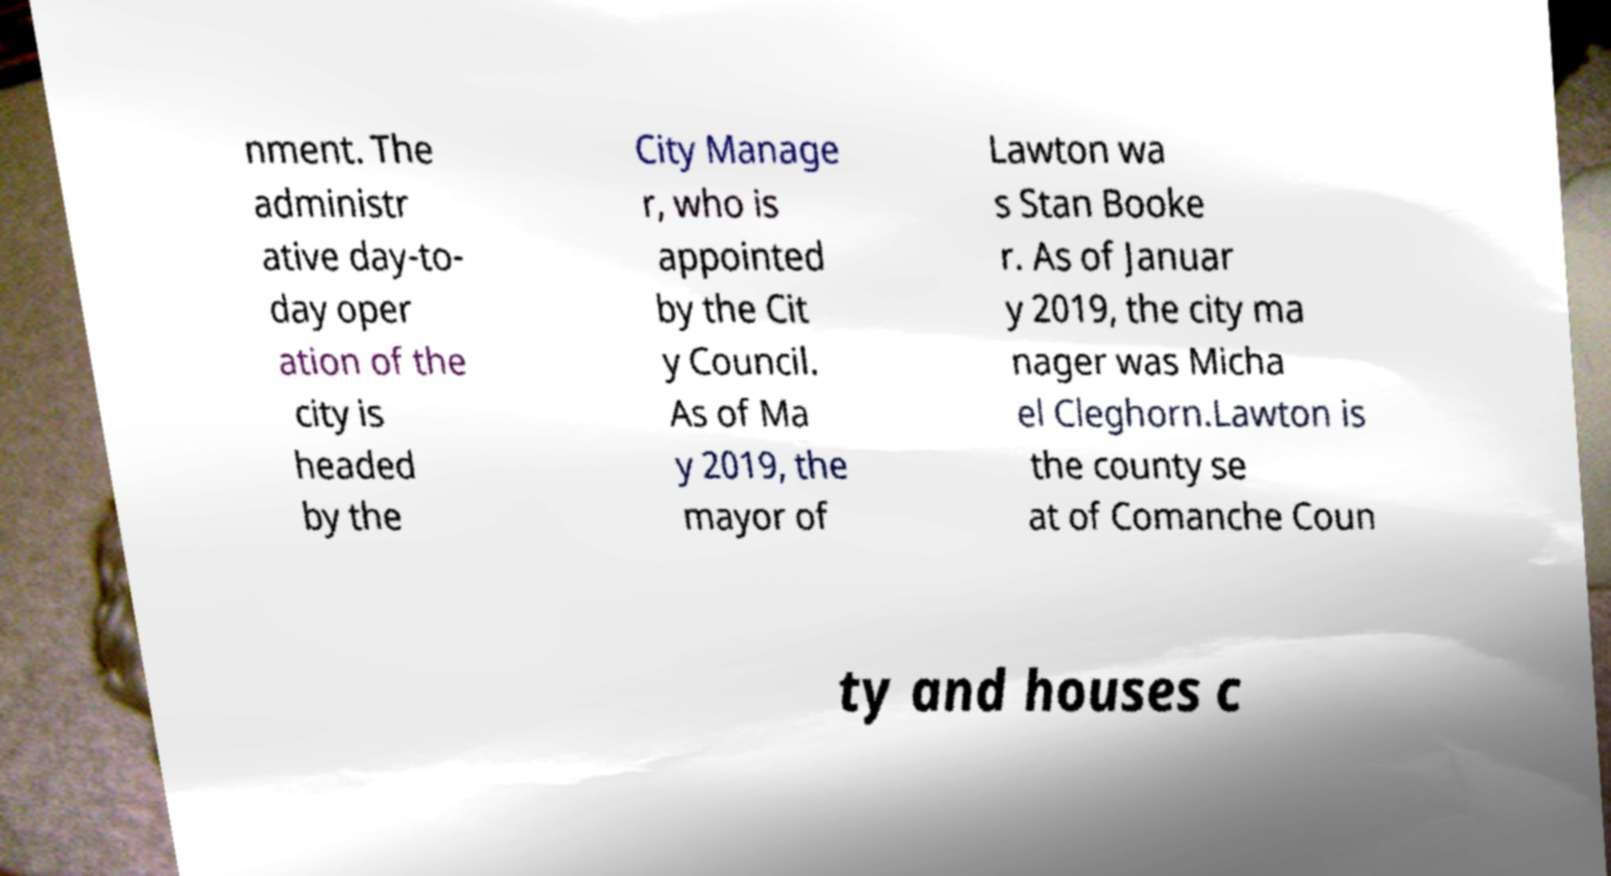Please identify and transcribe the text found in this image. nment. The administr ative day-to- day oper ation of the city is headed by the City Manage r, who is appointed by the Cit y Council. As of Ma y 2019, the mayor of Lawton wa s Stan Booke r. As of Januar y 2019, the city ma nager was Micha el Cleghorn.Lawton is the county se at of Comanche Coun ty and houses c 